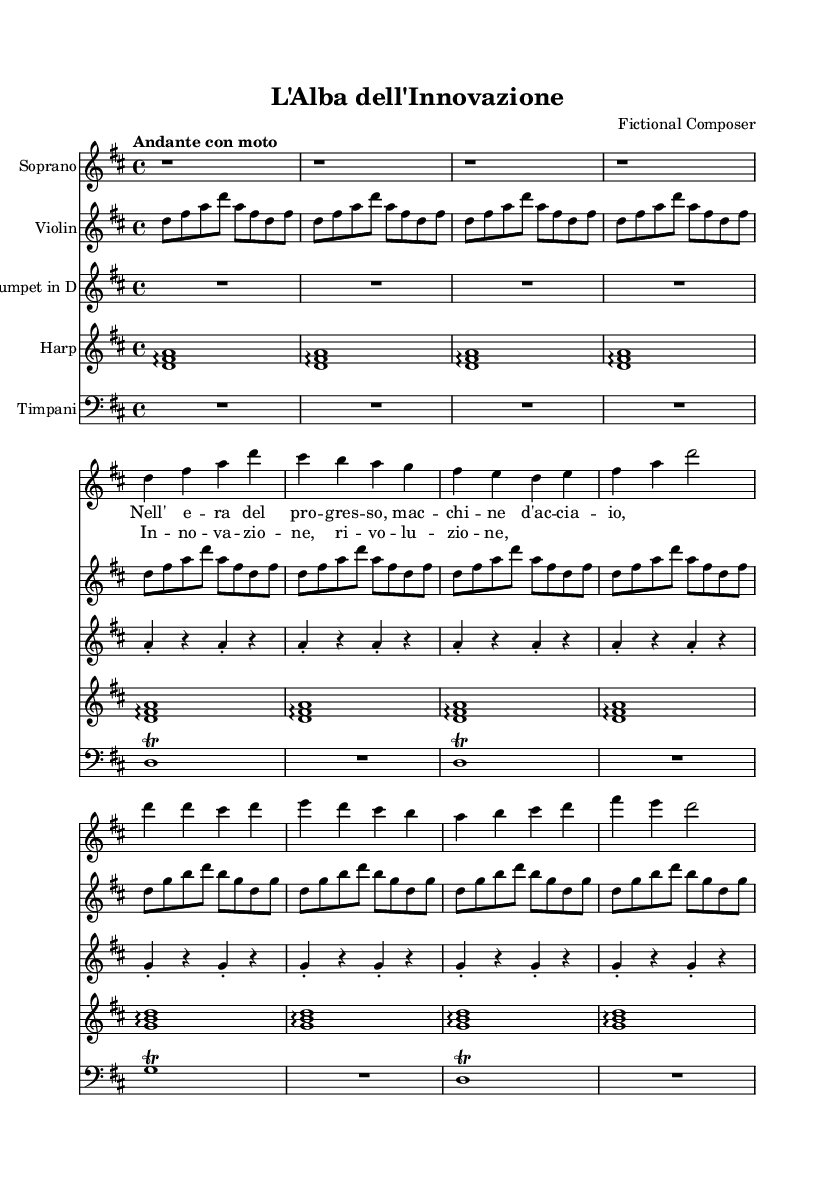What is the key signature of this music? The key signature is D major, which contains two sharps (F# and C#). This can be determined by looking at the key signature indicator at the beginning of the staff.
Answer: D major What is the time signature of this music? The time signature is 4/4, which indicates that there are four beats per measure and a quarter note receives one beat. This is listed at the beginning of the music beside the key signature.
Answer: 4/4 What is the tempo marking of the music? The tempo marking is "Andante con moto," which suggests a walking pace with some motion. The tempo is commonly indicated at the beginning of the score.
Answer: Andante con moto How many instruments are featured in this score? There are five instruments featured in this score: Soprano, Violin, Trumpet in D, Harp, and Timpani. Each instrument has its own dedicated staff in the score.
Answer: Five What are the themes conveyed in the lyrics of the Soprano? The themes conveyed are "progress" and "innovation," which are directly mentioned in the lyrics related to the ideas expressed in the music. The thematic elements can be identified by looking at the lyrics set above the corresponding notation.
Answer: Progress and innovation What is the structure of the vocal part in this opera piece? The structure of the vocal part consists of an introduction, a verse, and a chorus. These sections are distinct and can be identified by their musical notation and lyric placement.
Answer: Introduction, Verse, Chorus Which instrument plays the introduction of this music? The Harp plays the introduction of this music, as indicated by the repeated arpeggios in the score at the beginning. The introduction lines up with the initial measures where the Harp staff is notated.
Answer: Harp 